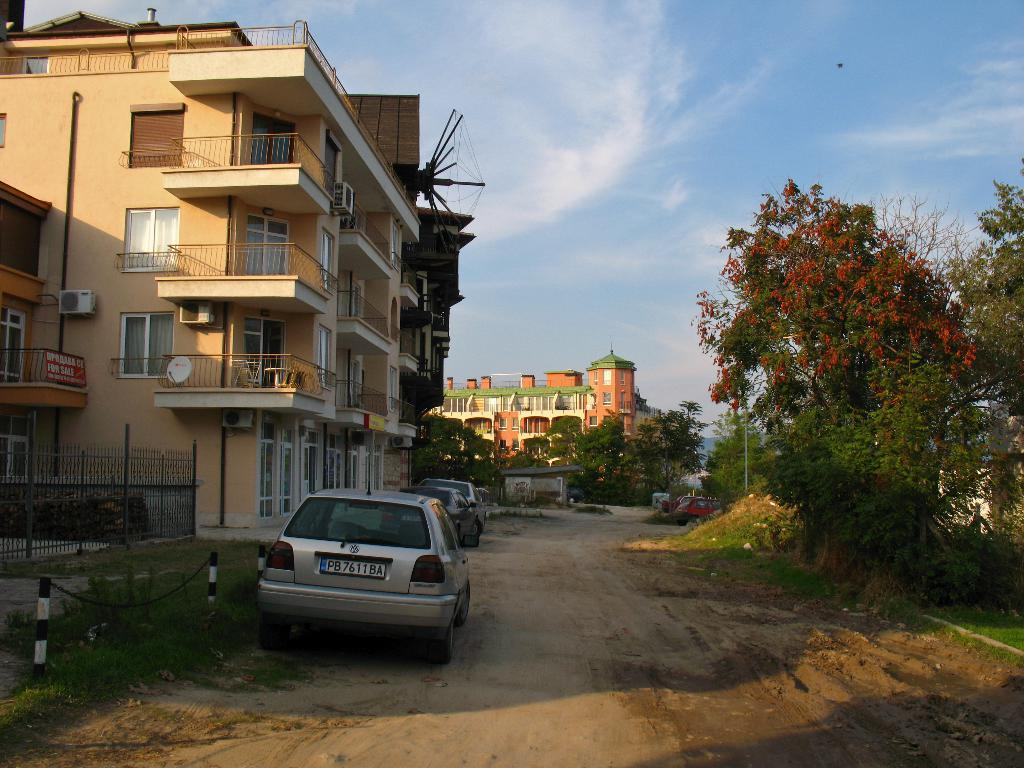What types of objects are on the ground in the image? There are vehicles on the ground in the image. What can be seen on the left side of the image? There are buildings and a fence on the left side of the image, as well as the sky. What is present on the right side of the image? There are trees and grass on the right side of the image. How many yaks can be seen grazing in the grass on the right side of the image? There are no yaks present in the image; it features vehicles, buildings, a fence, trees, and grass. What type of currency is visible on the left side of the image? There is no currency present in the image; it features buildings, a fence, and the sky. 